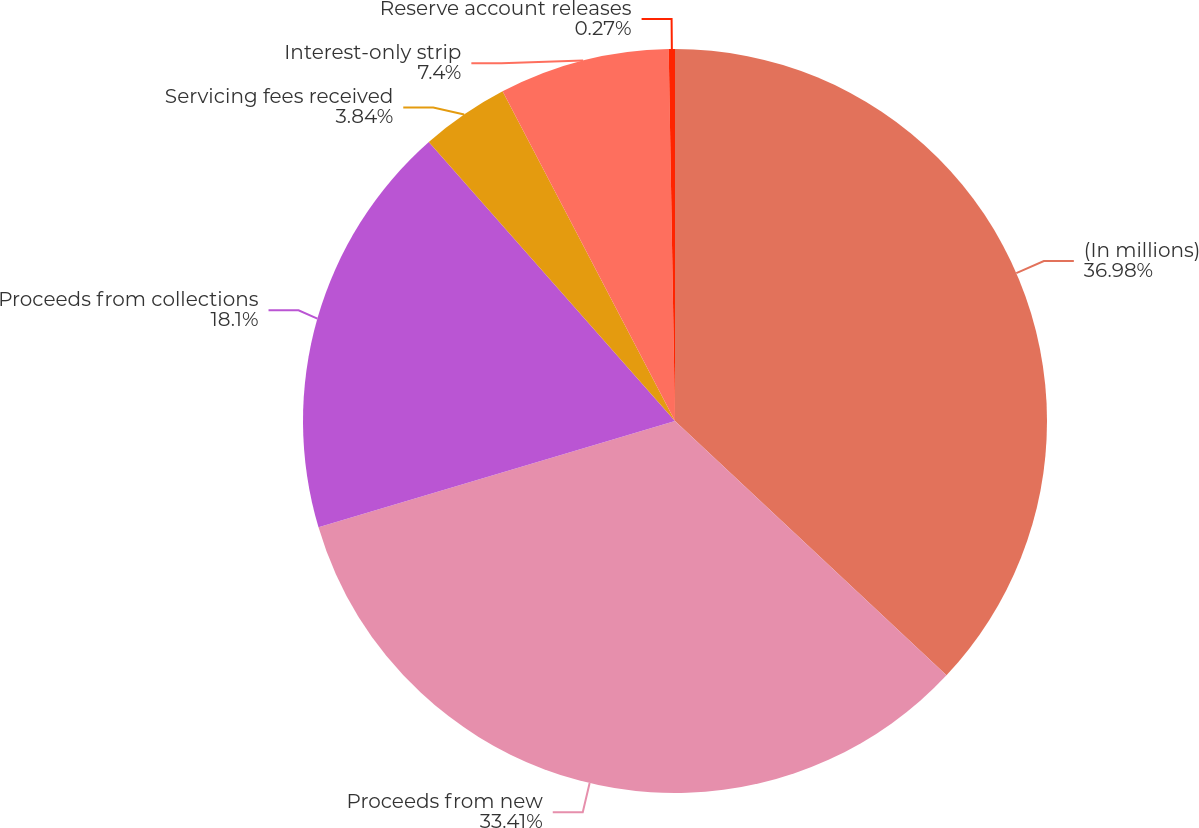Convert chart. <chart><loc_0><loc_0><loc_500><loc_500><pie_chart><fcel>(In millions)<fcel>Proceeds from new<fcel>Proceeds from collections<fcel>Servicing fees received<fcel>Interest-only strip<fcel>Reserve account releases<nl><fcel>36.98%<fcel>33.41%<fcel>18.1%<fcel>3.84%<fcel>7.4%<fcel>0.27%<nl></chart> 